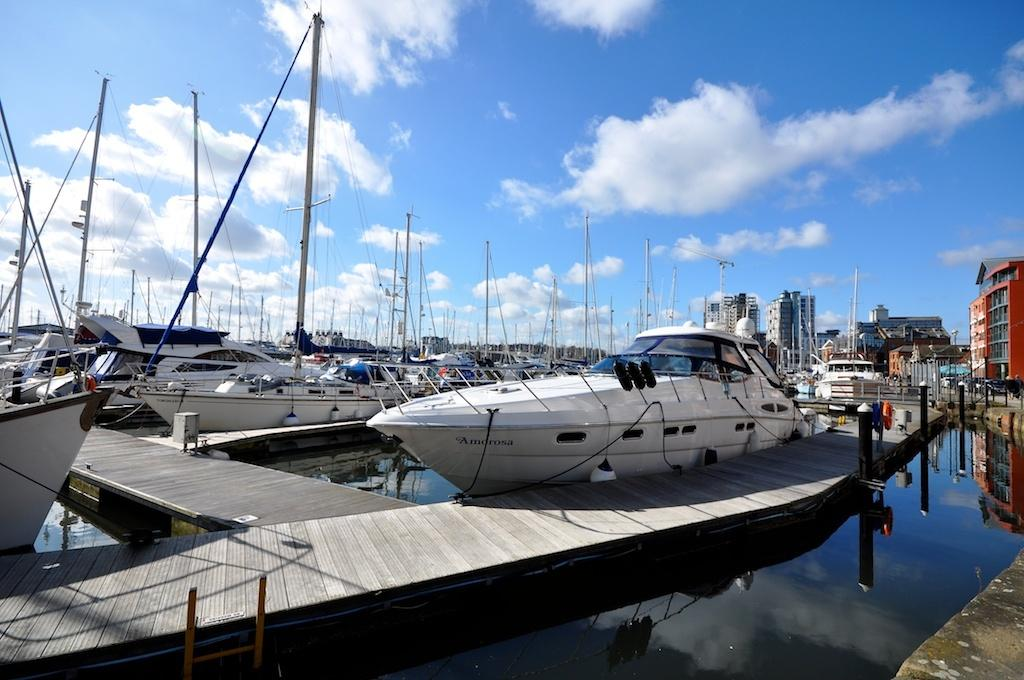What is in the water in the image? There are boats in the water in the image. What type of structures can be seen in the image? There are buildings in the image. What material are the poles made of in the image? The poles in the image are made of iron. What can be seen in the background of the image? The sky is visible in the background of the image. Can you see a snake slithering on the iron poles in the image? There is no snake present in the image; it only features boats, buildings, iron poles, and the sky. What type of lunch is being served in the image? There is no lunch depicted in the image; it focuses on boats, buildings, iron poles, and the sky. 